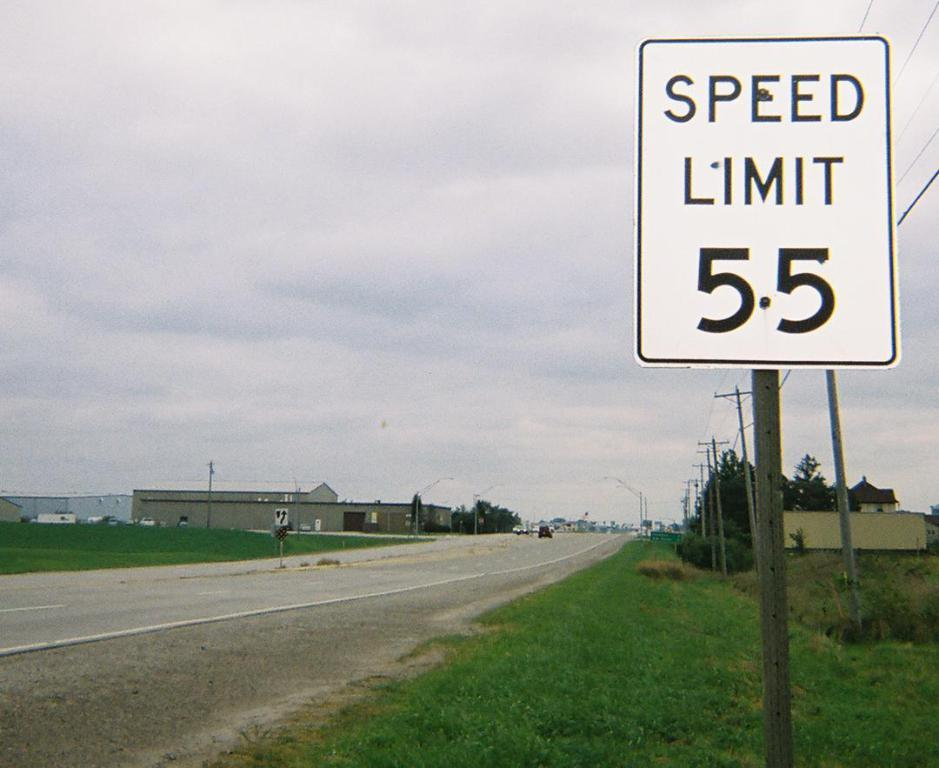<image>
Provide a brief description of the given image. White street sign which says Speed limit at 55. 